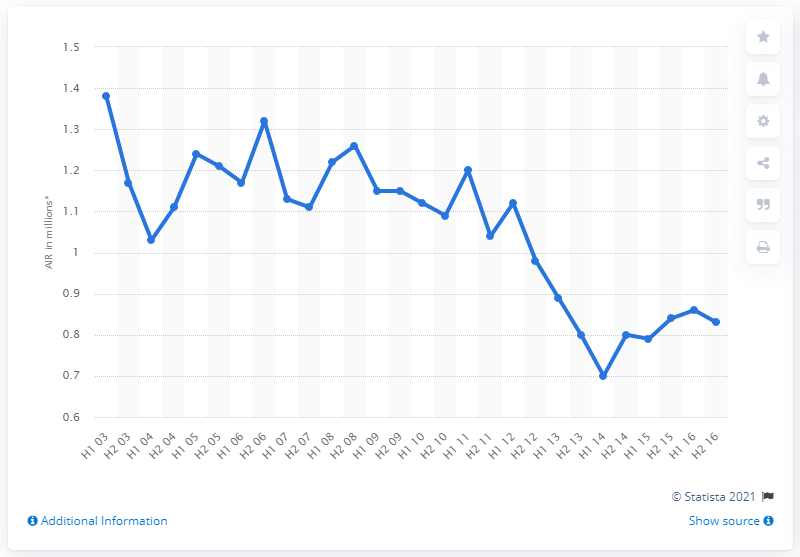Give some essential details in this illustration. The average readership of The Guardian from July to December 2015 was 0.84. 